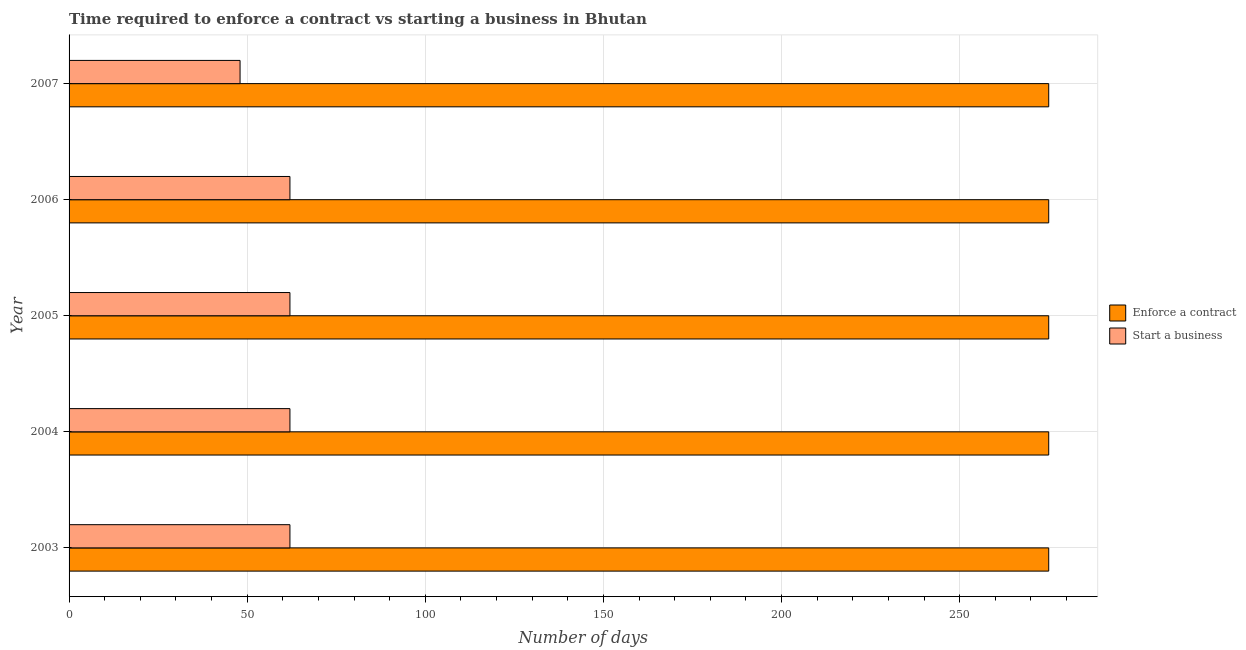How many different coloured bars are there?
Ensure brevity in your answer.  2. Are the number of bars on each tick of the Y-axis equal?
Your response must be concise. Yes. How many bars are there on the 2nd tick from the top?
Your answer should be very brief. 2. How many bars are there on the 3rd tick from the bottom?
Ensure brevity in your answer.  2. What is the label of the 1st group of bars from the top?
Give a very brief answer. 2007. What is the number of days to start a business in 2004?
Your answer should be compact. 62. Across all years, what is the maximum number of days to start a business?
Offer a very short reply. 62. Across all years, what is the minimum number of days to enforece a contract?
Keep it short and to the point. 275. What is the total number of days to enforece a contract in the graph?
Your answer should be very brief. 1375. What is the difference between the number of days to start a business in 2003 and that in 2006?
Offer a terse response. 0. What is the difference between the number of days to enforece a contract in 2006 and the number of days to start a business in 2004?
Provide a succinct answer. 213. What is the average number of days to start a business per year?
Your answer should be compact. 59.2. In the year 2006, what is the difference between the number of days to enforece a contract and number of days to start a business?
Your answer should be very brief. 213. In how many years, is the number of days to enforece a contract greater than 170 days?
Offer a terse response. 5. What is the ratio of the number of days to start a business in 2004 to that in 2007?
Your response must be concise. 1.29. Is the number of days to enforece a contract in 2006 less than that in 2007?
Your answer should be compact. No. What is the difference between the highest and the second highest number of days to start a business?
Your response must be concise. 0. What is the difference between the highest and the lowest number of days to enforece a contract?
Offer a very short reply. 0. Is the sum of the number of days to enforece a contract in 2003 and 2006 greater than the maximum number of days to start a business across all years?
Provide a short and direct response. Yes. What does the 2nd bar from the top in 2006 represents?
Offer a very short reply. Enforce a contract. What does the 2nd bar from the bottom in 2005 represents?
Offer a very short reply. Start a business. Are all the bars in the graph horizontal?
Offer a very short reply. Yes. How many years are there in the graph?
Provide a succinct answer. 5. Are the values on the major ticks of X-axis written in scientific E-notation?
Keep it short and to the point. No. How are the legend labels stacked?
Provide a short and direct response. Vertical. What is the title of the graph?
Keep it short and to the point. Time required to enforce a contract vs starting a business in Bhutan. Does "Resident workers" appear as one of the legend labels in the graph?
Ensure brevity in your answer.  No. What is the label or title of the X-axis?
Give a very brief answer. Number of days. What is the label or title of the Y-axis?
Make the answer very short. Year. What is the Number of days in Enforce a contract in 2003?
Your response must be concise. 275. What is the Number of days in Enforce a contract in 2004?
Provide a succinct answer. 275. What is the Number of days in Start a business in 2004?
Provide a short and direct response. 62. What is the Number of days of Enforce a contract in 2005?
Your answer should be compact. 275. What is the Number of days of Enforce a contract in 2006?
Ensure brevity in your answer.  275. What is the Number of days in Enforce a contract in 2007?
Offer a terse response. 275. Across all years, what is the maximum Number of days in Enforce a contract?
Provide a succinct answer. 275. Across all years, what is the minimum Number of days in Enforce a contract?
Your response must be concise. 275. Across all years, what is the minimum Number of days of Start a business?
Offer a terse response. 48. What is the total Number of days in Enforce a contract in the graph?
Ensure brevity in your answer.  1375. What is the total Number of days in Start a business in the graph?
Ensure brevity in your answer.  296. What is the difference between the Number of days in Start a business in 2003 and that in 2005?
Give a very brief answer. 0. What is the difference between the Number of days in Enforce a contract in 2003 and that in 2007?
Give a very brief answer. 0. What is the difference between the Number of days of Start a business in 2003 and that in 2007?
Offer a terse response. 14. What is the difference between the Number of days in Enforce a contract in 2004 and that in 2006?
Your answer should be very brief. 0. What is the difference between the Number of days of Start a business in 2004 and that in 2006?
Provide a succinct answer. 0. What is the difference between the Number of days in Enforce a contract in 2006 and that in 2007?
Your answer should be compact. 0. What is the difference between the Number of days of Start a business in 2006 and that in 2007?
Give a very brief answer. 14. What is the difference between the Number of days of Enforce a contract in 2003 and the Number of days of Start a business in 2004?
Give a very brief answer. 213. What is the difference between the Number of days in Enforce a contract in 2003 and the Number of days in Start a business in 2005?
Keep it short and to the point. 213. What is the difference between the Number of days in Enforce a contract in 2003 and the Number of days in Start a business in 2006?
Your response must be concise. 213. What is the difference between the Number of days in Enforce a contract in 2003 and the Number of days in Start a business in 2007?
Give a very brief answer. 227. What is the difference between the Number of days in Enforce a contract in 2004 and the Number of days in Start a business in 2005?
Ensure brevity in your answer.  213. What is the difference between the Number of days of Enforce a contract in 2004 and the Number of days of Start a business in 2006?
Your response must be concise. 213. What is the difference between the Number of days in Enforce a contract in 2004 and the Number of days in Start a business in 2007?
Give a very brief answer. 227. What is the difference between the Number of days of Enforce a contract in 2005 and the Number of days of Start a business in 2006?
Ensure brevity in your answer.  213. What is the difference between the Number of days in Enforce a contract in 2005 and the Number of days in Start a business in 2007?
Provide a succinct answer. 227. What is the difference between the Number of days of Enforce a contract in 2006 and the Number of days of Start a business in 2007?
Provide a short and direct response. 227. What is the average Number of days in Enforce a contract per year?
Give a very brief answer. 275. What is the average Number of days in Start a business per year?
Offer a terse response. 59.2. In the year 2003, what is the difference between the Number of days in Enforce a contract and Number of days in Start a business?
Give a very brief answer. 213. In the year 2004, what is the difference between the Number of days of Enforce a contract and Number of days of Start a business?
Your response must be concise. 213. In the year 2005, what is the difference between the Number of days of Enforce a contract and Number of days of Start a business?
Keep it short and to the point. 213. In the year 2006, what is the difference between the Number of days of Enforce a contract and Number of days of Start a business?
Your answer should be very brief. 213. In the year 2007, what is the difference between the Number of days of Enforce a contract and Number of days of Start a business?
Provide a succinct answer. 227. What is the ratio of the Number of days of Enforce a contract in 2003 to that in 2004?
Provide a short and direct response. 1. What is the ratio of the Number of days in Enforce a contract in 2003 to that in 2005?
Ensure brevity in your answer.  1. What is the ratio of the Number of days of Start a business in 2003 to that in 2005?
Provide a succinct answer. 1. What is the ratio of the Number of days in Enforce a contract in 2003 to that in 2006?
Ensure brevity in your answer.  1. What is the ratio of the Number of days of Enforce a contract in 2003 to that in 2007?
Provide a short and direct response. 1. What is the ratio of the Number of days in Start a business in 2003 to that in 2007?
Provide a short and direct response. 1.29. What is the ratio of the Number of days of Start a business in 2004 to that in 2005?
Your answer should be very brief. 1. What is the ratio of the Number of days of Enforce a contract in 2004 to that in 2006?
Your answer should be compact. 1. What is the ratio of the Number of days of Enforce a contract in 2004 to that in 2007?
Your answer should be compact. 1. What is the ratio of the Number of days in Start a business in 2004 to that in 2007?
Keep it short and to the point. 1.29. What is the ratio of the Number of days in Enforce a contract in 2005 to that in 2007?
Your answer should be compact. 1. What is the ratio of the Number of days of Start a business in 2005 to that in 2007?
Your response must be concise. 1.29. What is the ratio of the Number of days of Enforce a contract in 2006 to that in 2007?
Your response must be concise. 1. What is the ratio of the Number of days in Start a business in 2006 to that in 2007?
Offer a very short reply. 1.29. 